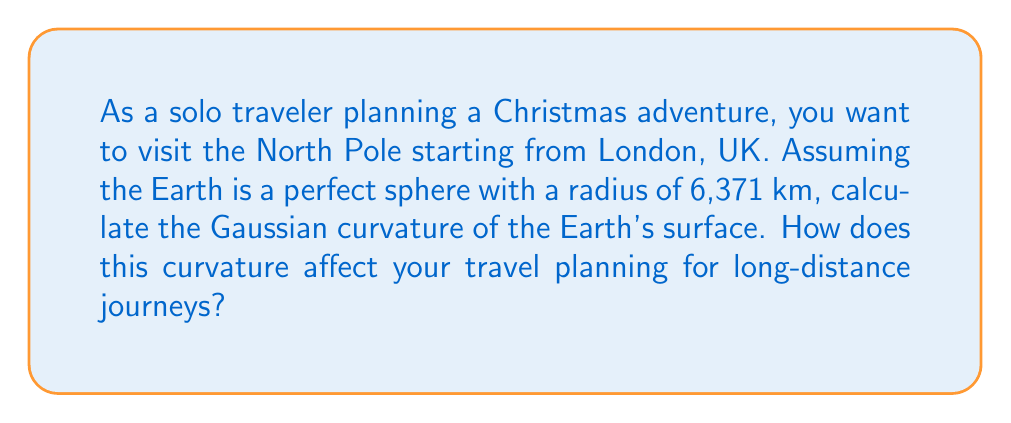Can you answer this question? To solve this problem, we need to understand the concept of Gaussian curvature for a sphere and its implications for long-distance travel planning.

1. Gaussian curvature of a sphere:
   The Gaussian curvature (K) of a sphere with radius R is constant and given by:

   $$K = \frac{1}{R^2}$$

2. Calculate the curvature:
   Given: Radius of Earth, R = 6,371 km
   
   $$K = \frac{1}{(6,371 \text{ km})^2} = 2.46 \times 10^{-8} \text{ km}^{-2}$$

3. Implications for long-distance travel planning:
   a) Great circles: The curvature of the Earth means that the shortest path between two points on the surface is along a great circle, not a straight line on a flat map.
   
   b) Distance calculation: The distance (d) between two points on a sphere is given by the great circle distance formula:
      
      $$d = R \times \arccos(\sin(\phi_1)\sin(\phi_2) + \cos(\phi_1)\cos(\phi_2)\cos(\Delta \lambda))$$
      
      where $\phi_1, \phi_2$ are latitudes and $\Delta \lambda$ is the difference in longitudes.

   c) Map projections: Due to the Earth's curvature, all flat map projections introduce distortions in either shape, area, or distance.

   d) Flight paths: Long-distance flights often follow great circle routes, which may appear curved on flat maps but are actually the shortest paths on the spherical Earth.

   e) Time zones: The curvature of the Earth leads to the need for time zones, which affects travel planning across long distances.

For the solo traveler planning a trip to the North Pole from London:
- The traveler needs to consider that the shortest route will follow a great circle path.
- Distance calculations must account for the Earth's curvature using spherical geometry.
- The traveler should be aware that flat map representations may not accurately depict the true path or distances.
- Time zone changes will be significant, affecting travel schedules and local event times for Christmas celebrations.

[asy]
import geometry;

size(200);
real R = 5;
path p = circle((0,0), R);
draw(p);
dot((0,0), blue);
draw((0,0)--(R,0), blue);
label("R", (R/2,0), S);
label("Earth", (0,-R-0.5));
draw((-R-1,0)--(R+1,0), dashed);
draw((0,-R-1)--(0,R+1), dashed);
dot((0,R), red);
label("North Pole", (0,R+0.5), N);
dot((R*cos(51.5*pi/180), R*sin(51.5*pi/180)), green);
label("London", (R*cos(51.5*pi/180), R*sin(51.5*pi/180)), SE);
draw(arc((0,0), (R*cos(51.5*pi/180), R*sin(51.5*pi/180)), (0,R)), red);
[/asy]
Answer: The Gaussian curvature of the Earth's surface, modeled as a perfect sphere, is $2.46 \times 10^{-8} \text{ km}^{-2}$. This curvature significantly affects long-distance travel planning by necessitating the use of great circle routes, spherical distance calculations, consideration of map projection distortions, and awareness of time zone changes. 